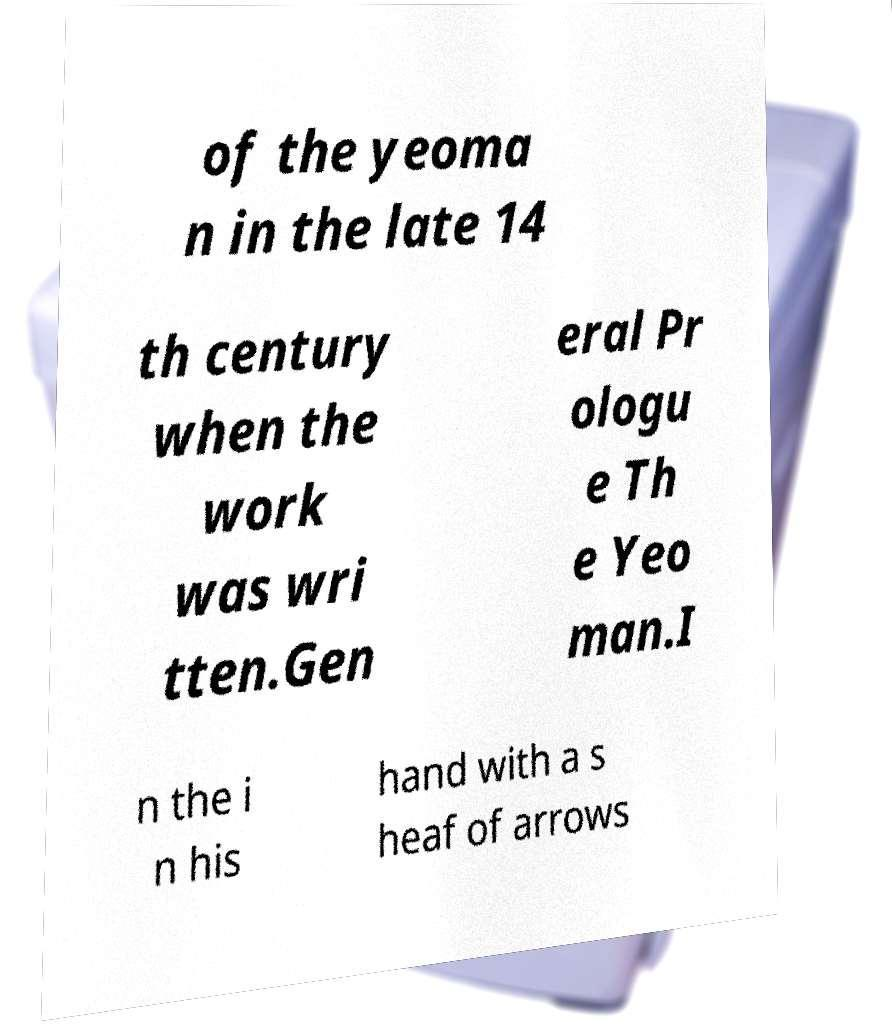What messages or text are displayed in this image? I need them in a readable, typed format. of the yeoma n in the late 14 th century when the work was wri tten.Gen eral Pr ologu e Th e Yeo man.I n the i n his hand with a s heaf of arrows 